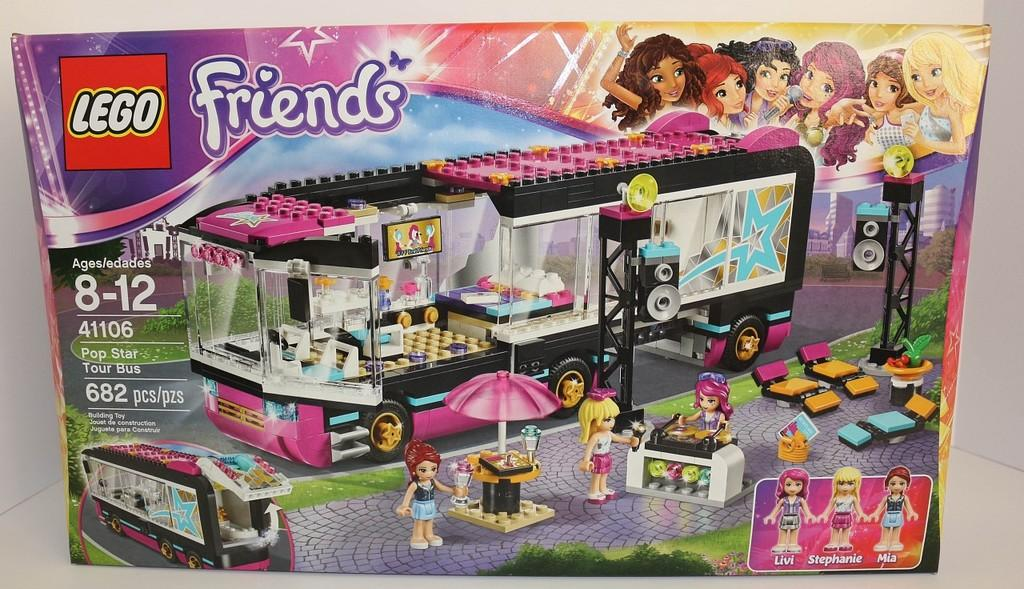What is featured in the image? There is a poster and a Barbie dolls set in the image. What can be seen on the poster? Words are written on the poster. Can you describe the Barbie dolls set? The Barbie dolls set is visible in the image. What type of poison is being used to draw the line on the poster? There is no poison or line present on the poster in the image. 